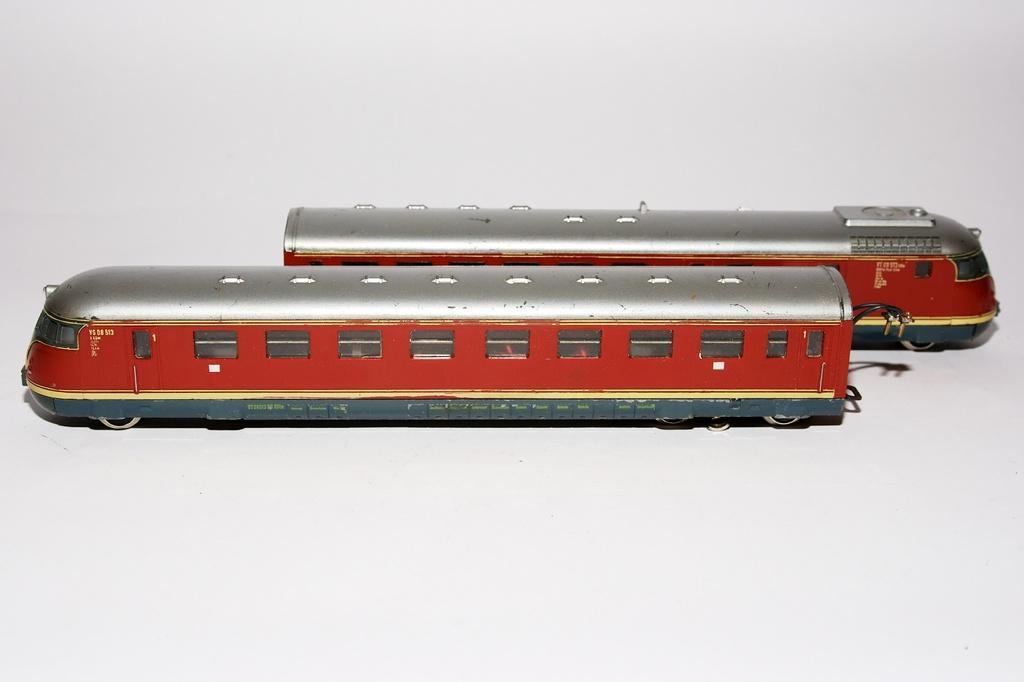How would you summarize this image in a sentence or two? In this picture we can see toy trains on a white surface. 